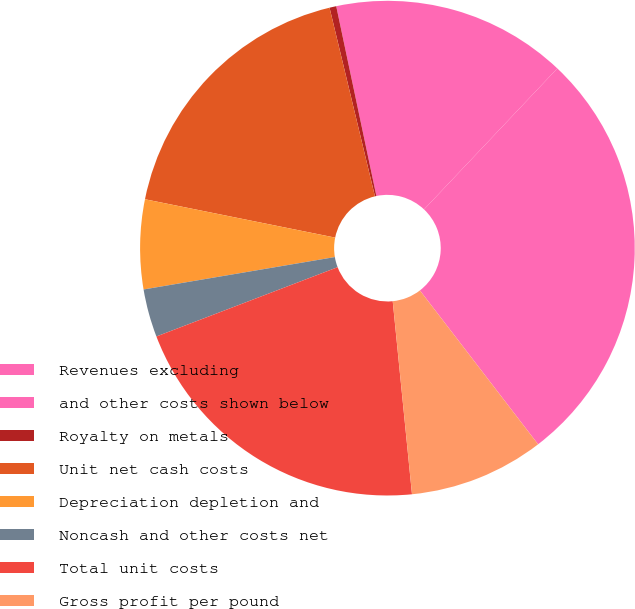Convert chart. <chart><loc_0><loc_0><loc_500><loc_500><pie_chart><fcel>Revenues excluding<fcel>and other costs shown below<fcel>Royalty on metals<fcel>Unit net cash costs<fcel>Depreciation depletion and<fcel>Noncash and other costs net<fcel>Total unit costs<fcel>Gross profit per pound<nl><fcel>27.52%<fcel>15.37%<fcel>0.44%<fcel>18.07%<fcel>5.84%<fcel>3.14%<fcel>20.77%<fcel>8.84%<nl></chart> 